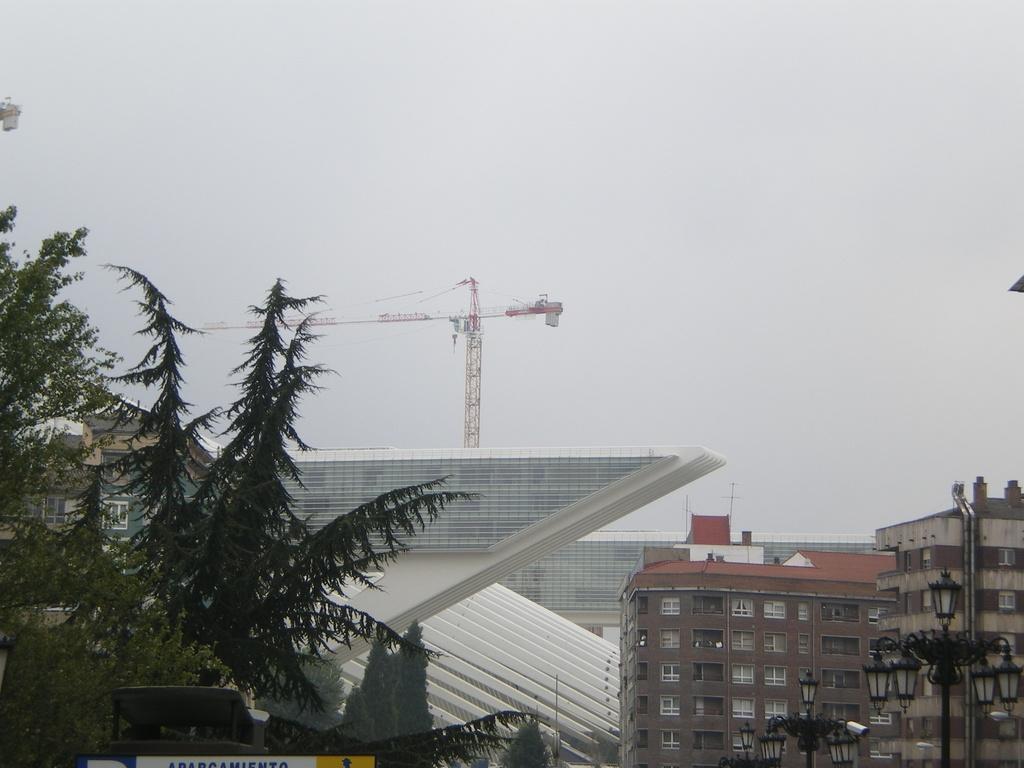Could you give a brief overview of what you see in this image? In this picture there are buildings, trees, and poles in the image and there is a tower in the background area of the image. 